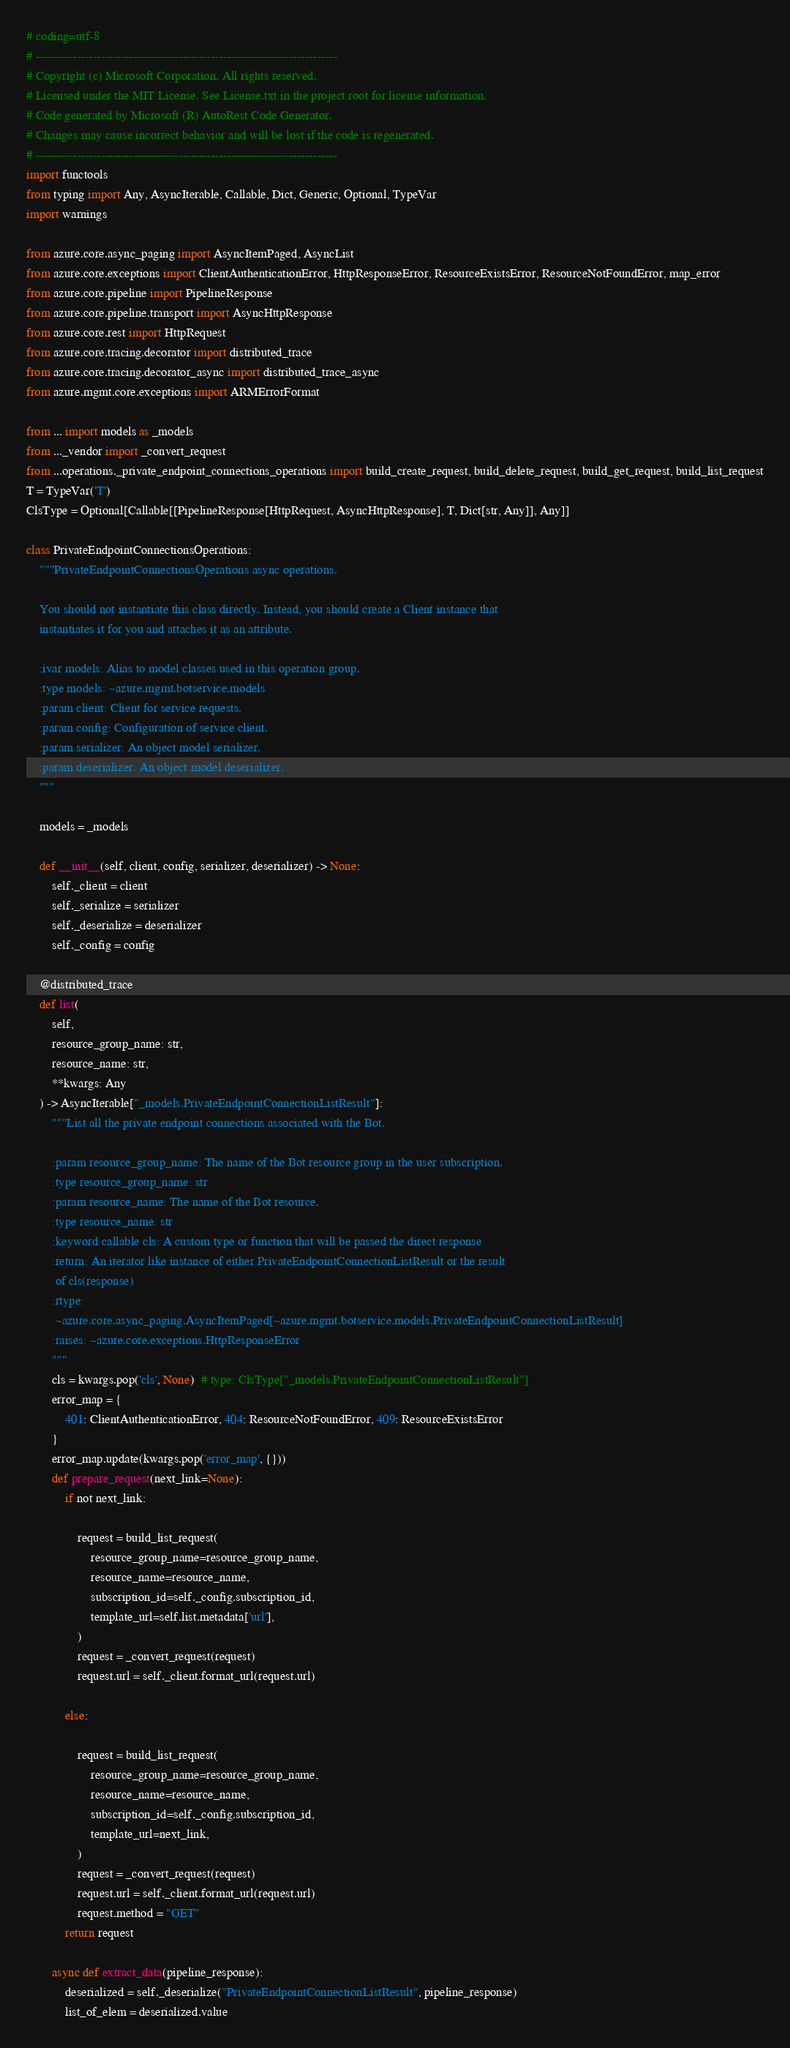<code> <loc_0><loc_0><loc_500><loc_500><_Python_># coding=utf-8
# --------------------------------------------------------------------------
# Copyright (c) Microsoft Corporation. All rights reserved.
# Licensed under the MIT License. See License.txt in the project root for license information.
# Code generated by Microsoft (R) AutoRest Code Generator.
# Changes may cause incorrect behavior and will be lost if the code is regenerated.
# --------------------------------------------------------------------------
import functools
from typing import Any, AsyncIterable, Callable, Dict, Generic, Optional, TypeVar
import warnings

from azure.core.async_paging import AsyncItemPaged, AsyncList
from azure.core.exceptions import ClientAuthenticationError, HttpResponseError, ResourceExistsError, ResourceNotFoundError, map_error
from azure.core.pipeline import PipelineResponse
from azure.core.pipeline.transport import AsyncHttpResponse
from azure.core.rest import HttpRequest
from azure.core.tracing.decorator import distributed_trace
from azure.core.tracing.decorator_async import distributed_trace_async
from azure.mgmt.core.exceptions import ARMErrorFormat

from ... import models as _models
from ..._vendor import _convert_request
from ...operations._private_endpoint_connections_operations import build_create_request, build_delete_request, build_get_request, build_list_request
T = TypeVar('T')
ClsType = Optional[Callable[[PipelineResponse[HttpRequest, AsyncHttpResponse], T, Dict[str, Any]], Any]]

class PrivateEndpointConnectionsOperations:
    """PrivateEndpointConnectionsOperations async operations.

    You should not instantiate this class directly. Instead, you should create a Client instance that
    instantiates it for you and attaches it as an attribute.

    :ivar models: Alias to model classes used in this operation group.
    :type models: ~azure.mgmt.botservice.models
    :param client: Client for service requests.
    :param config: Configuration of service client.
    :param serializer: An object model serializer.
    :param deserializer: An object model deserializer.
    """

    models = _models

    def __init__(self, client, config, serializer, deserializer) -> None:
        self._client = client
        self._serialize = serializer
        self._deserialize = deserializer
        self._config = config

    @distributed_trace
    def list(
        self,
        resource_group_name: str,
        resource_name: str,
        **kwargs: Any
    ) -> AsyncIterable["_models.PrivateEndpointConnectionListResult"]:
        """List all the private endpoint connections associated with the Bot.

        :param resource_group_name: The name of the Bot resource group in the user subscription.
        :type resource_group_name: str
        :param resource_name: The name of the Bot resource.
        :type resource_name: str
        :keyword callable cls: A custom type or function that will be passed the direct response
        :return: An iterator like instance of either PrivateEndpointConnectionListResult or the result
         of cls(response)
        :rtype:
         ~azure.core.async_paging.AsyncItemPaged[~azure.mgmt.botservice.models.PrivateEndpointConnectionListResult]
        :raises: ~azure.core.exceptions.HttpResponseError
        """
        cls = kwargs.pop('cls', None)  # type: ClsType["_models.PrivateEndpointConnectionListResult"]
        error_map = {
            401: ClientAuthenticationError, 404: ResourceNotFoundError, 409: ResourceExistsError
        }
        error_map.update(kwargs.pop('error_map', {}))
        def prepare_request(next_link=None):
            if not next_link:
                
                request = build_list_request(
                    resource_group_name=resource_group_name,
                    resource_name=resource_name,
                    subscription_id=self._config.subscription_id,
                    template_url=self.list.metadata['url'],
                )
                request = _convert_request(request)
                request.url = self._client.format_url(request.url)

            else:
                
                request = build_list_request(
                    resource_group_name=resource_group_name,
                    resource_name=resource_name,
                    subscription_id=self._config.subscription_id,
                    template_url=next_link,
                )
                request = _convert_request(request)
                request.url = self._client.format_url(request.url)
                request.method = "GET"
            return request

        async def extract_data(pipeline_response):
            deserialized = self._deserialize("PrivateEndpointConnectionListResult", pipeline_response)
            list_of_elem = deserialized.value</code> 